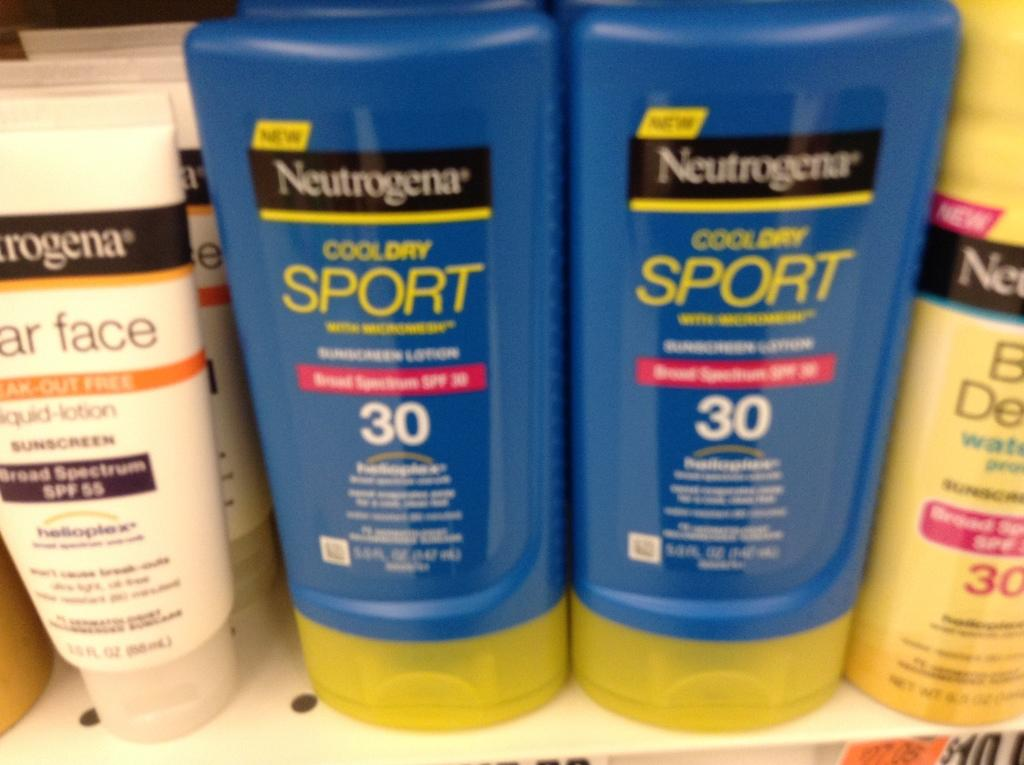<image>
Create a compact narrative representing the image presented. two bottles of neutrogena cool dry sport next to each other on a shelf 